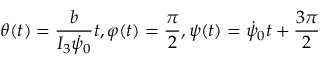<formula> <loc_0><loc_0><loc_500><loc_500>\theta ( t ) = \frac { b } { I _ { 3 } \dot { \psi } _ { 0 } } t , \varphi ( t ) = \frac { \pi } { 2 } , \psi ( t ) = \dot { \psi } _ { 0 } t + \frac { 3 \pi } { 2 }</formula> 